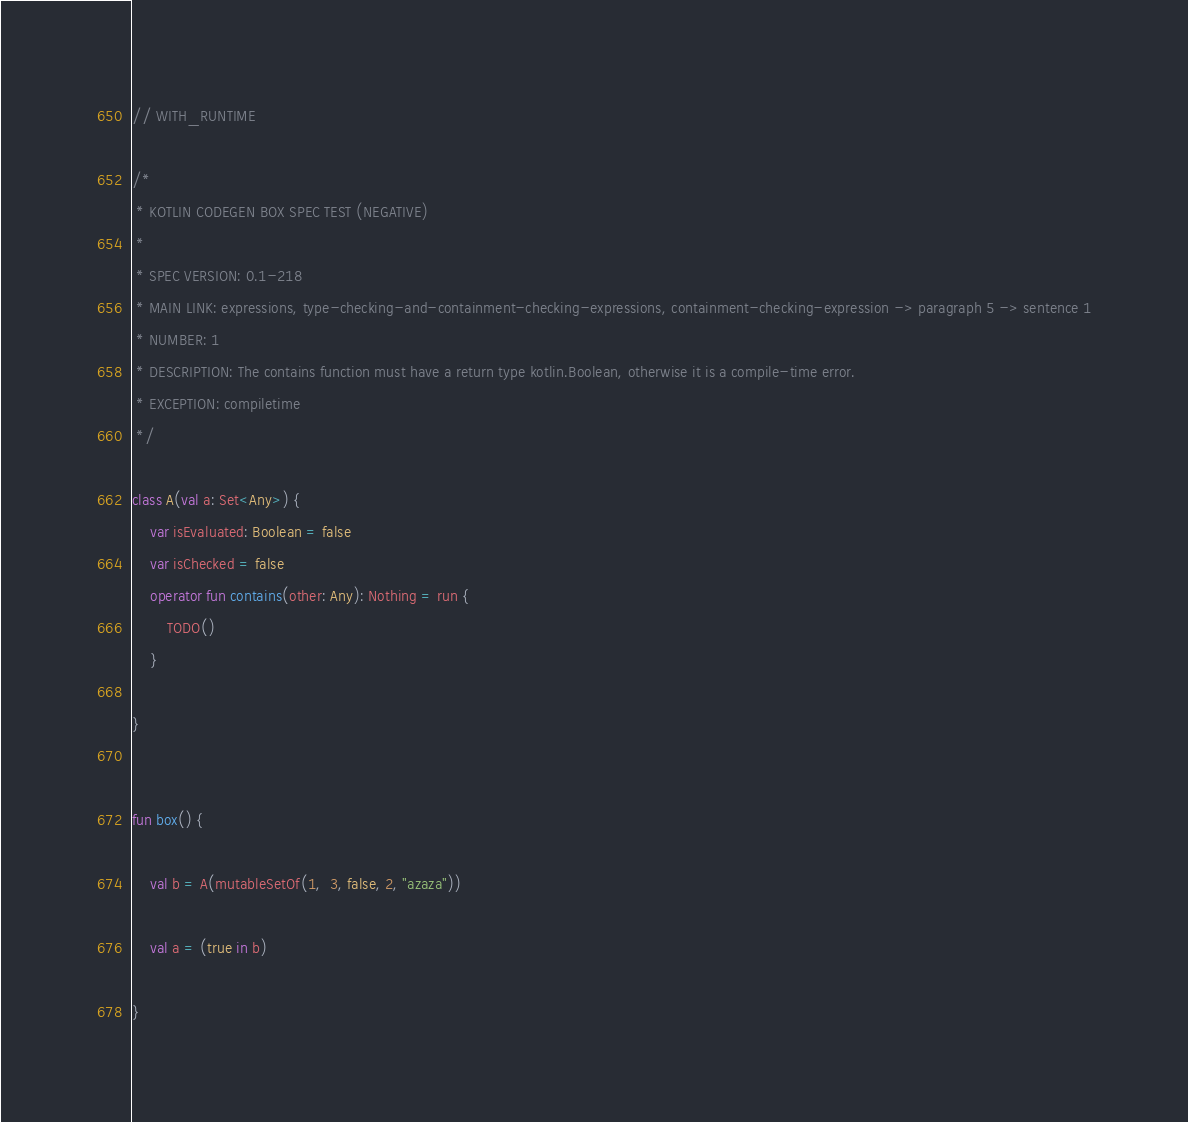Convert code to text. <code><loc_0><loc_0><loc_500><loc_500><_Kotlin_>// WITH_RUNTIME

/*
 * KOTLIN CODEGEN BOX SPEC TEST (NEGATIVE)
 *
 * SPEC VERSION: 0.1-218
 * MAIN LINK: expressions, type-checking-and-containment-checking-expressions, containment-checking-expression -> paragraph 5 -> sentence 1
 * NUMBER: 1
 * DESCRIPTION: The contains function must have a return type kotlin.Boolean, otherwise it is a compile-time error.
 * EXCEPTION: compiletime
 */

class A(val a: Set<Any>) {
    var isEvaluated: Boolean = false
    var isChecked = false
    operator fun contains(other: Any): Nothing = run {
        TODO()
    }

}


fun box() {

    val b = A(mutableSetOf(1,  3, false, 2, "azaza"))

    val a = (true in b)

}</code> 